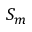Convert formula to latex. <formula><loc_0><loc_0><loc_500><loc_500>S _ { m }</formula> 